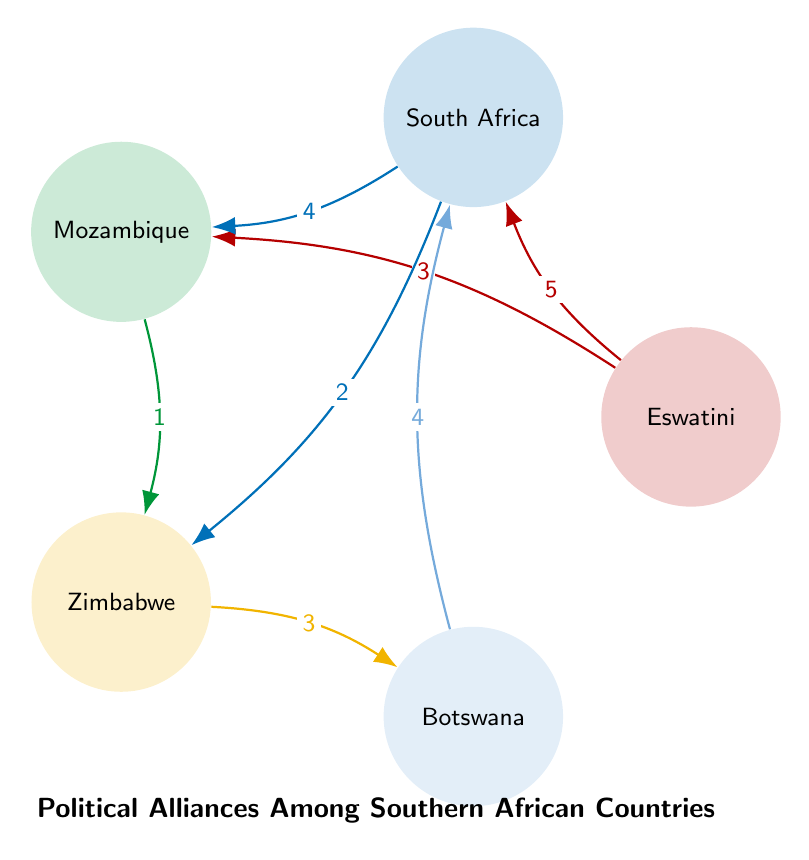What is the value of the connection between Eswatini and South Africa? The value of the connection between Eswatini and South Africa is represented on the chord connecting these two nodes and is labeled with the number 5.
Answer: 5 How many nodes are present in this diagram? The diagram lists five countries as nodes: Eswatini, South Africa, Mozambique, Zimbabwe, and Botswana. Therefore, the total number of nodes is 5.
Answer: 5 Which country has the strongest alliance with South Africa? The strongest alliance with South Africa is indicated by the connection labeled with the highest value linked to South Africa. The strongest link is to Eswatini, with a value of 5.
Answer: Eswatini What is the value of the connection between Zimbabwe and Botswana? The value of the connection between Zimbabwe and Botswana is indicated on the chord connecting the two nodes, which is labeled with the number 3.
Answer: 3 Which two countries have a connection value of 1? The connection value of 1 is shown between Mozambique and Zimbabwe, indicating the weakest alliance in the diagram.
Answer: Mozambique and Zimbabwe Which country has connections to both Eswatini and Zimbabwe? The country that connects to both Eswatini and Zimbabwe is South Africa, as it has links to both these nations in the diagram.
Answer: South Africa What percentage of the connections originate from Eswatini? To determine the percentage of connections from Eswatini, look at the links: it has 2 connections out of a total of 7 (5 + 3 + 4 + 2 + 1 + 3 + 4 = 7), which calculates to 28.57%.
Answer: 28.57% What is the total value of connections originating from South Africa? The total value of connections from South Africa is calculated by adding the values of its connections: 5 (to Eswatini) + 4 (to Mozambique) + 2 (to Zimbabwe) + 4 (to Botswana), which equals 15.
Answer: 15 How many connections does Zimbabwe have? Zimbabwe has two connections: one to South Africa (value 2) and one to Botswana (value 3), totaling two connections in the diagram.
Answer: 2 What is the minimum connection value in the diagram? The minimum connection value in the diagram is indicated on the link between Mozambique and Zimbabwe, which is labeled with the number 1.
Answer: 1 